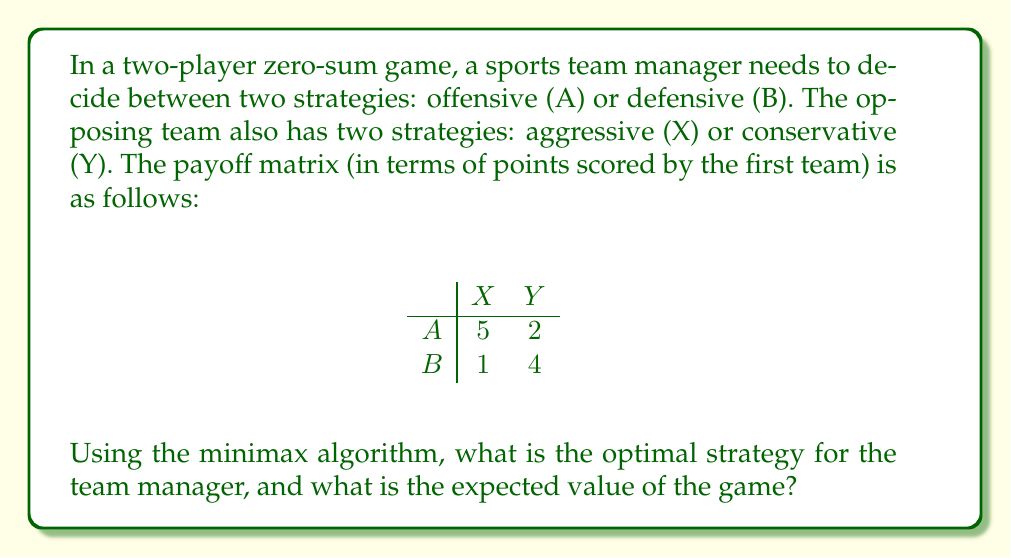Show me your answer to this math problem. To solve this problem using the minimax algorithm, we'll follow these steps:

1) First, we need to find the minimax and maximin values:

   For strategy A: $\min(5, 2) = 2$
   For strategy B: $\min(1, 4) = 1$
   
   Maximin value = $\max(2, 1) = 2$

   For strategy X: $\max(5, 1) = 5$
   For strategy Y: $\max(2, 4) = 4$
   
   Minimax value = $\min(5, 4) = 4$

2) Since the maximin ≠ minimax, there's no pure strategy equilibrium. We need to find a mixed strategy.

3) Let $p$ be the probability of choosing strategy A, and $(1-p)$ for strategy B.

4) The expected value for the opponent choosing X is:
   $5p + 1(1-p) = 5p + 1 - p = 4p + 1$

5) The expected value for the opponent choosing Y is:
   $2p + 4(1-p) = 2p + 4 - 4p = 4 - 2p$

6) For the optimal mixed strategy, these should be equal:
   $4p + 1 = 4 - 2p$
   $6p = 3$
   $p = 1/2$

7) Therefore, the optimal strategy is to choose A and B with equal probability (1/2 each).

8) The expected value of the game is found by substituting $p = 1/2$ into either equation:
   $4(1/2) + 1 = 3$ or $4 - 2(1/2) = 3$

Thus, the expected value of the game is 3 points.
Answer: Optimal strategy: 50% A, 50% B. Expected value: 3 points. 